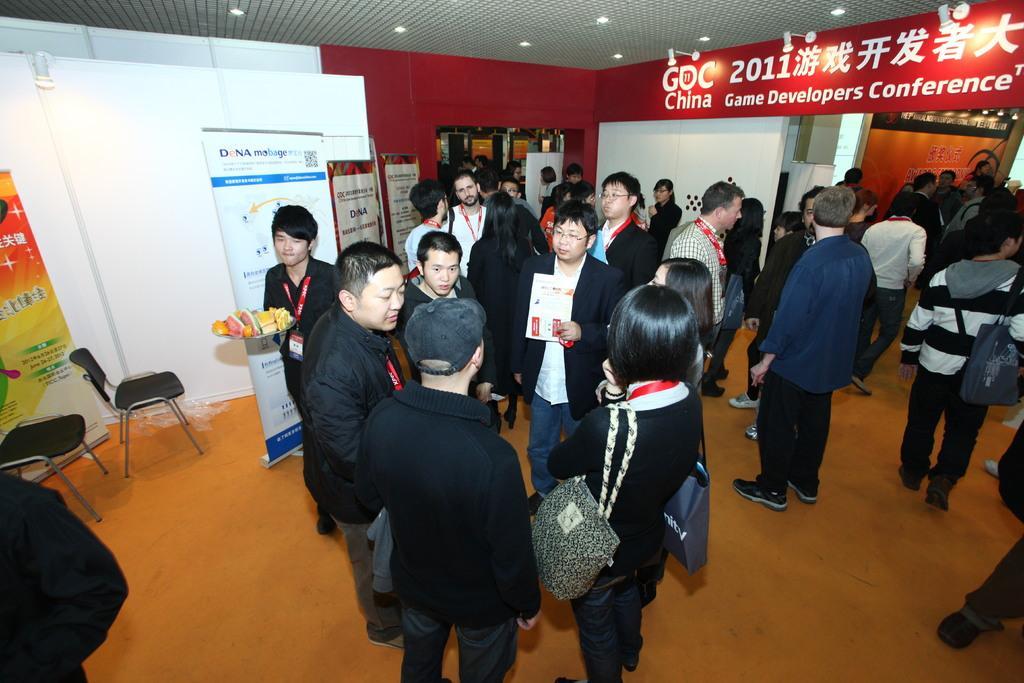In one or two sentences, can you explain what this image depicts? Here we can see group of people on the floor. There are chairs, banners, and boards. This is ceiling. Here we can see lights and wall. 